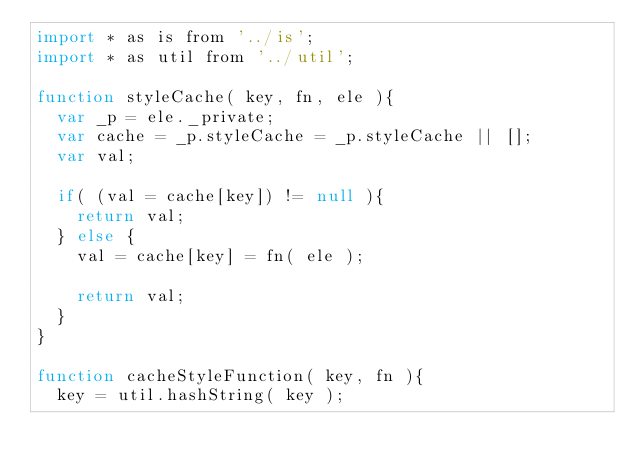Convert code to text. <code><loc_0><loc_0><loc_500><loc_500><_JavaScript_>import * as is from '../is';
import * as util from '../util';

function styleCache( key, fn, ele ){
  var _p = ele._private;
  var cache = _p.styleCache = _p.styleCache || [];
  var val;

  if( (val = cache[key]) != null ){
    return val;
  } else {
    val = cache[key] = fn( ele );

    return val;
  }
}

function cacheStyleFunction( key, fn ){
  key = util.hashString( key );
</code> 